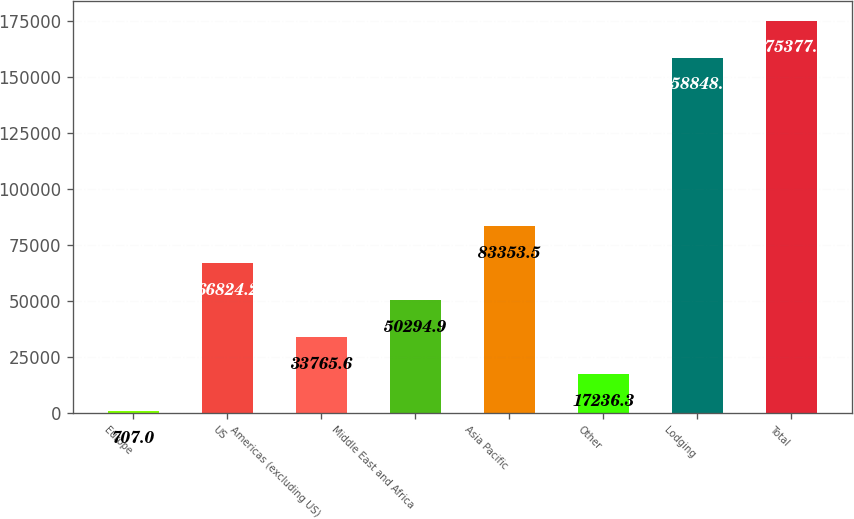<chart> <loc_0><loc_0><loc_500><loc_500><bar_chart><fcel>Europe<fcel>US<fcel>Americas (excluding US)<fcel>Middle East and Africa<fcel>Asia Pacific<fcel>Other<fcel>Lodging<fcel>Total<nl><fcel>707<fcel>66824.2<fcel>33765.6<fcel>50294.9<fcel>83353.5<fcel>17236.3<fcel>158848<fcel>175377<nl></chart> 